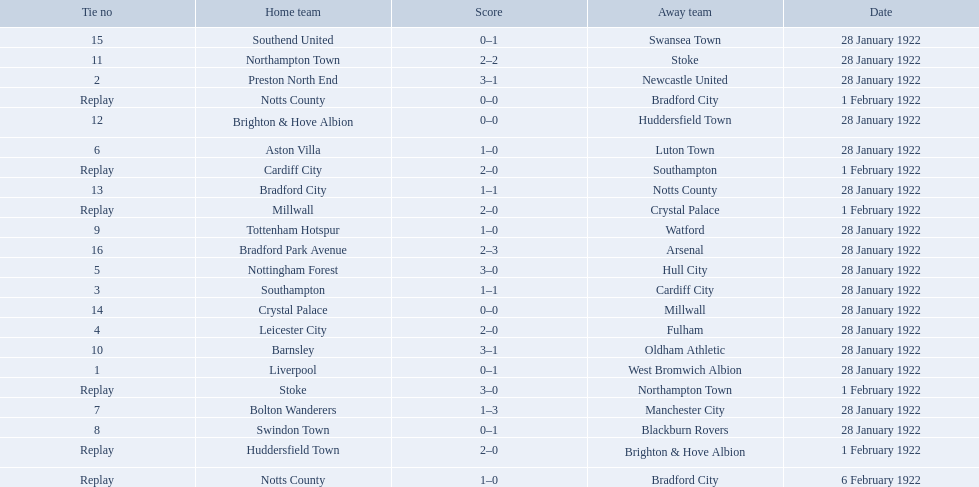What are all of the home teams? Liverpool, Preston North End, Southampton, Cardiff City, Leicester City, Nottingham Forest, Aston Villa, Bolton Wanderers, Swindon Town, Tottenham Hotspur, Barnsley, Northampton Town, Stoke, Brighton & Hove Albion, Huddersfield Town, Bradford City, Notts County, Notts County, Crystal Palace, Millwall, Southend United, Bradford Park Avenue. What were the scores? 0–1, 3–1, 1–1, 2–0, 2–0, 3–0, 1–0, 1–3, 0–1, 1–0, 3–1, 2–2, 3–0, 0–0, 2–0, 1–1, 0–0, 1–0, 0–0, 2–0, 0–1, 2–3. On which dates did they play? 28 January 1922, 28 January 1922, 28 January 1922, 1 February 1922, 28 January 1922, 28 January 1922, 28 January 1922, 28 January 1922, 28 January 1922, 28 January 1922, 28 January 1922, 28 January 1922, 1 February 1922, 28 January 1922, 1 February 1922, 28 January 1922, 1 February 1922, 6 February 1922, 28 January 1922, 1 February 1922, 28 January 1922, 28 January 1922. Which teams played on 28 january 1922? Liverpool, Preston North End, Southampton, Leicester City, Nottingham Forest, Aston Villa, Bolton Wanderers, Swindon Town, Tottenham Hotspur, Barnsley, Northampton Town, Brighton & Hove Albion, Bradford City, Crystal Palace, Southend United, Bradford Park Avenue. Of those, which scored the same as aston villa? Tottenham Hotspur. 